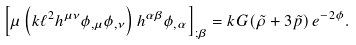<formula> <loc_0><loc_0><loc_500><loc_500>\left [ \mu \left ( k \ell ^ { 2 } h ^ { \mu \nu } \phi _ { , \mu } \phi _ { , \nu } \right ) h ^ { \alpha \beta } \phi _ { , \alpha } \right ] _ { ; \beta } = k G ( \tilde { \rho } + 3 \tilde { p } ) \, e ^ { - 2 \phi } .</formula> 